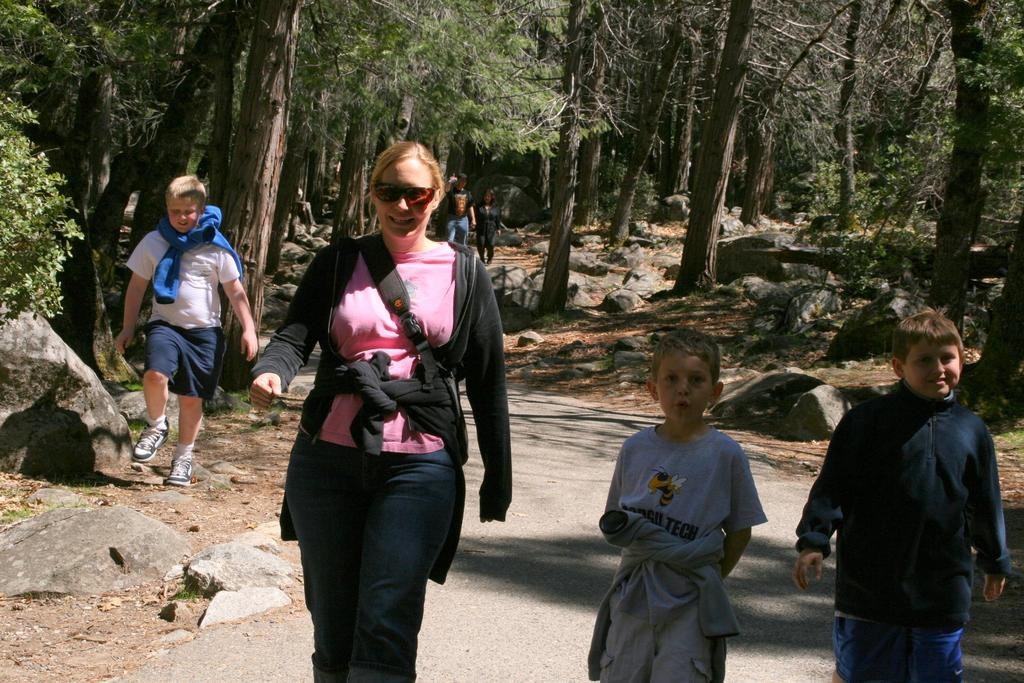What are the people in the image doing? The people in the image are walking on the ground. What type of natural features can be seen in the image? Rocks are present in the image. What can be seen in the distance in the image? There are trees in the background of the image. What type of corn can be seen growing near the rocks in the image? There is no corn present in the image; only rocks and trees are visible. 